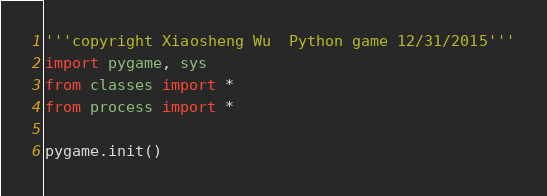<code> <loc_0><loc_0><loc_500><loc_500><_Python_>'''copyright Xiaosheng Wu  Python game 12/31/2015'''
import pygame, sys
from classes import *
from process import *

pygame.init()</code> 